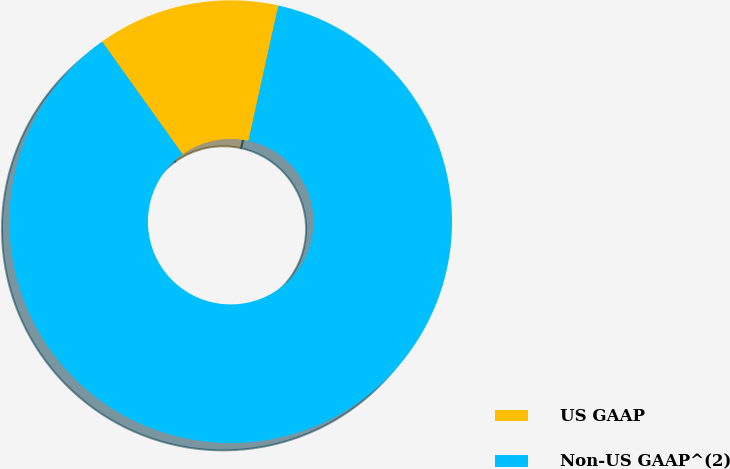Convert chart. <chart><loc_0><loc_0><loc_500><loc_500><pie_chart><fcel>US GAAP<fcel>Non-US GAAP^(2)<nl><fcel>13.33%<fcel>86.67%<nl></chart> 